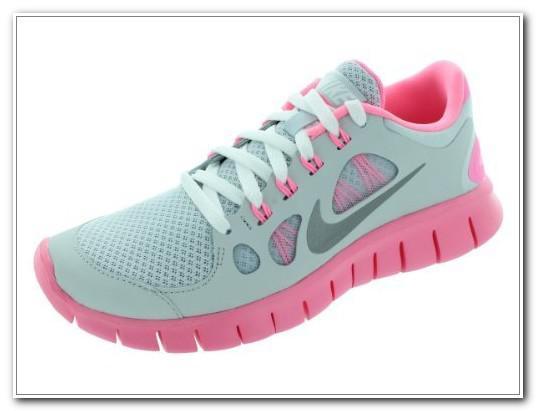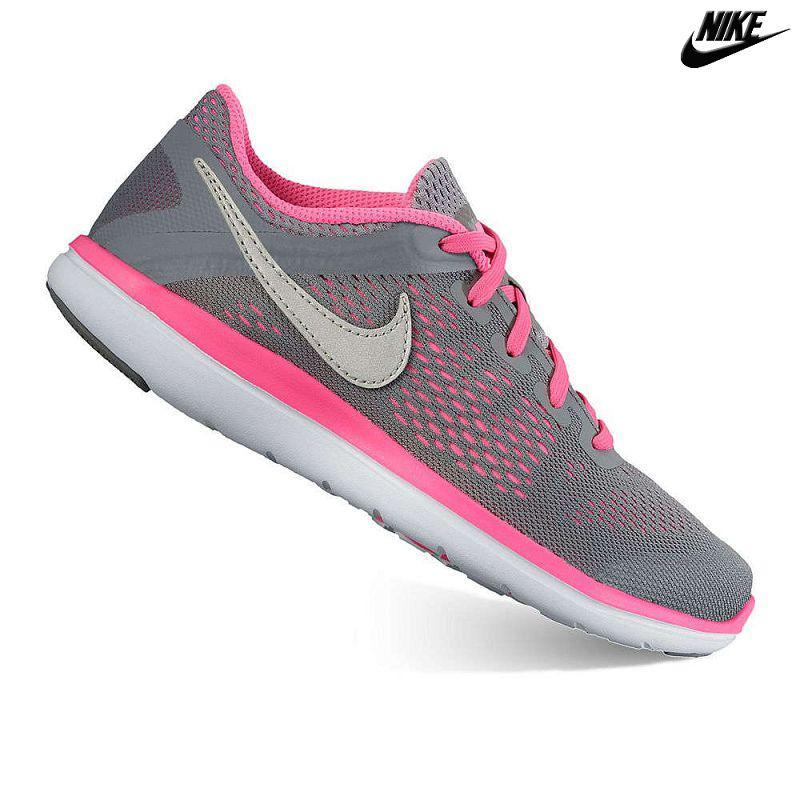The first image is the image on the left, the second image is the image on the right. Assess this claim about the two images: "Each image contains a single sneaker, and exactly one sneaker has pink laces.". Correct or not? Answer yes or no. Yes. The first image is the image on the left, the second image is the image on the right. Analyze the images presented: Is the assertion "A single shoe is shown in profile in each of the images." valid? Answer yes or no. Yes. 